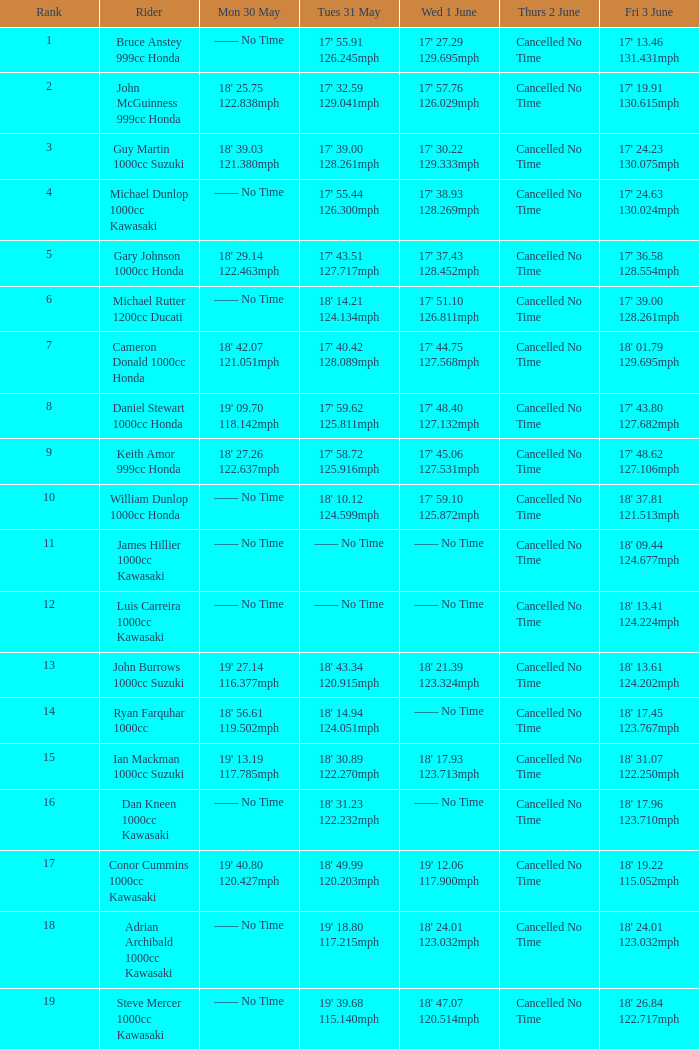431mph? —— No Time. 